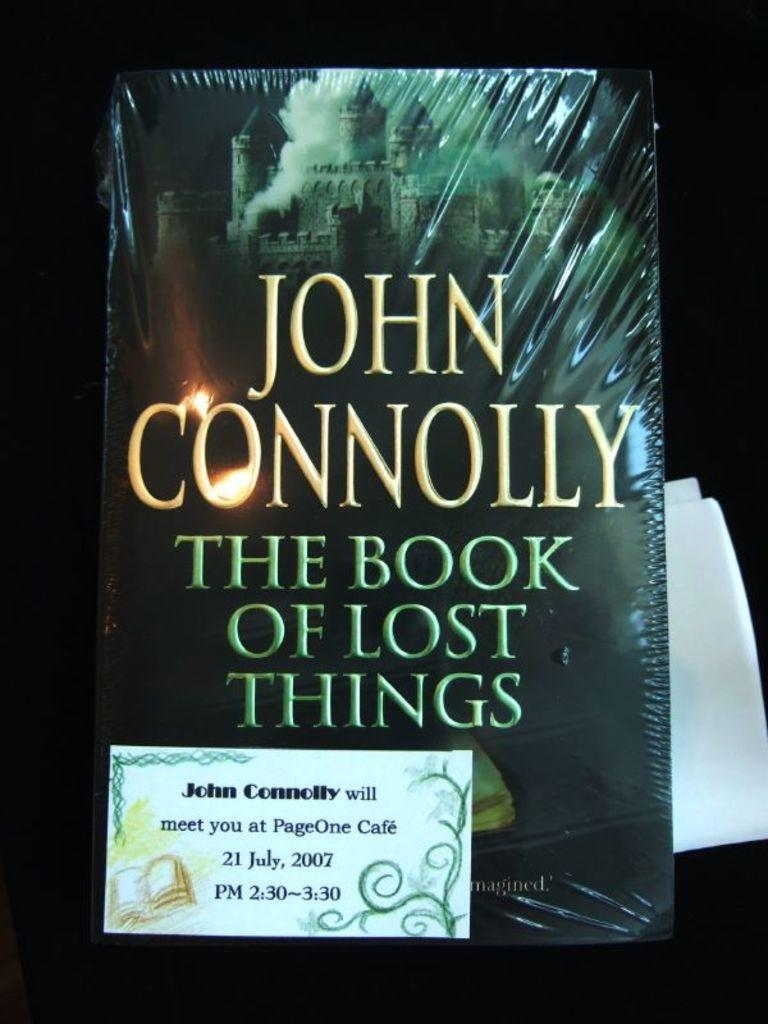<image>
Write a terse but informative summary of the picture. The Book of Lost Things by John Connolly standing up in front of paper. 